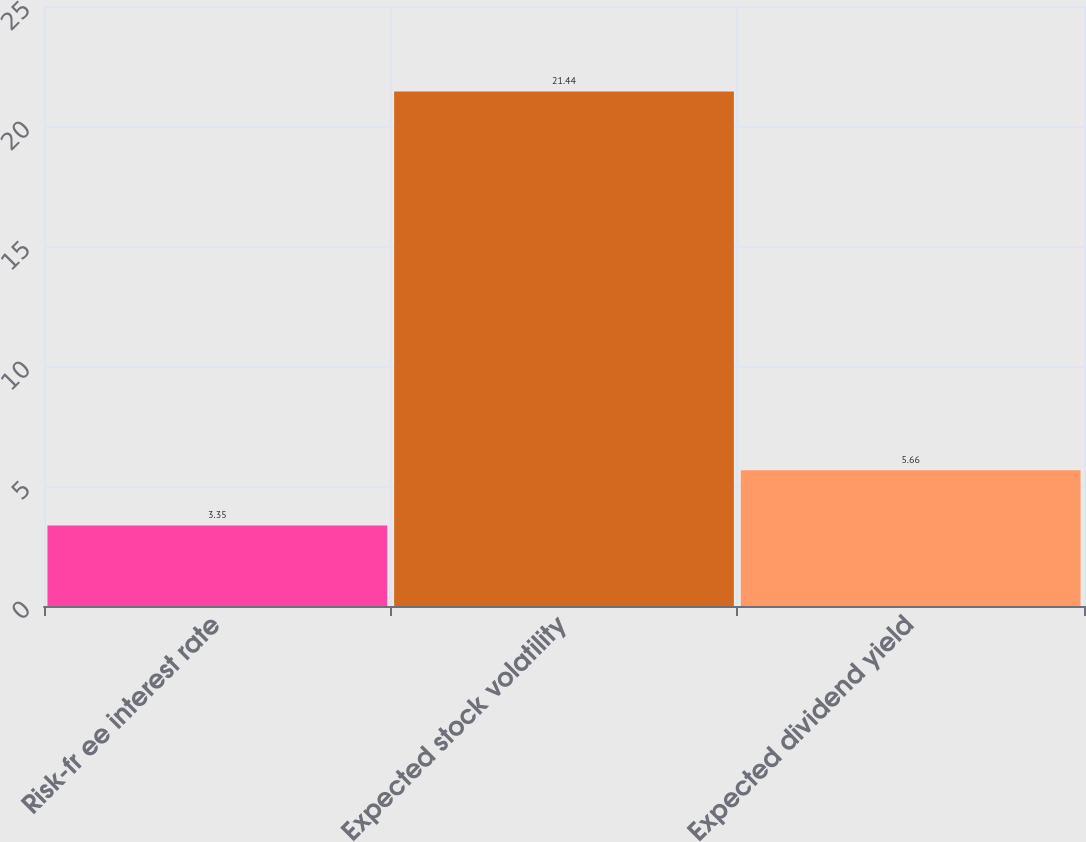Convert chart to OTSL. <chart><loc_0><loc_0><loc_500><loc_500><bar_chart><fcel>Risk-fr ee interest rate<fcel>Expected stock volatility<fcel>Expected dividend yield<nl><fcel>3.35<fcel>21.44<fcel>5.66<nl></chart> 